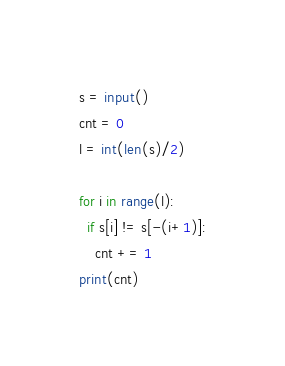Convert code to text. <code><loc_0><loc_0><loc_500><loc_500><_Python_>s = input()
cnt = 0
l = int(len(s)/2)

for i in range(l):
  if s[i] != s[-(i+1)]:
    cnt += 1
print(cnt)</code> 